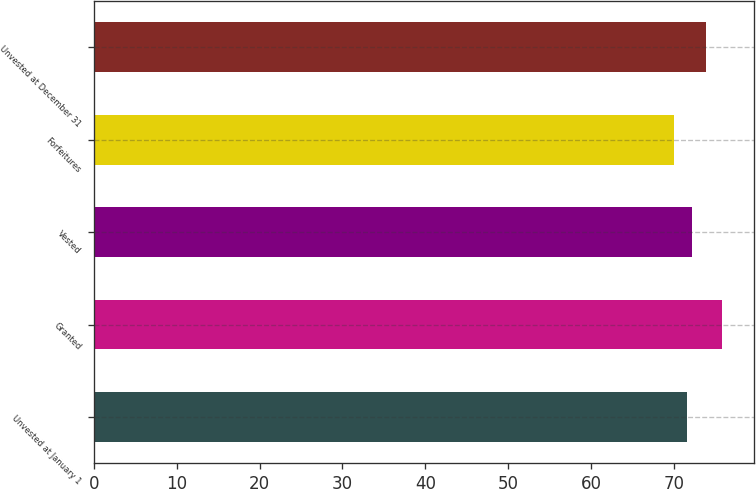Convert chart to OTSL. <chart><loc_0><loc_0><loc_500><loc_500><bar_chart><fcel>Unvested at January 1<fcel>Granted<fcel>Vested<fcel>Forfeitures<fcel>Unvested at December 31<nl><fcel>71.58<fcel>75.86<fcel>72.23<fcel>70.06<fcel>73.93<nl></chart> 